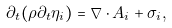Convert formula to latex. <formula><loc_0><loc_0><loc_500><loc_500>\partial _ { t } ( \rho \partial _ { t } \eta _ { i } ) = \nabla \cdot A _ { i } + \sigma _ { i } ,</formula> 